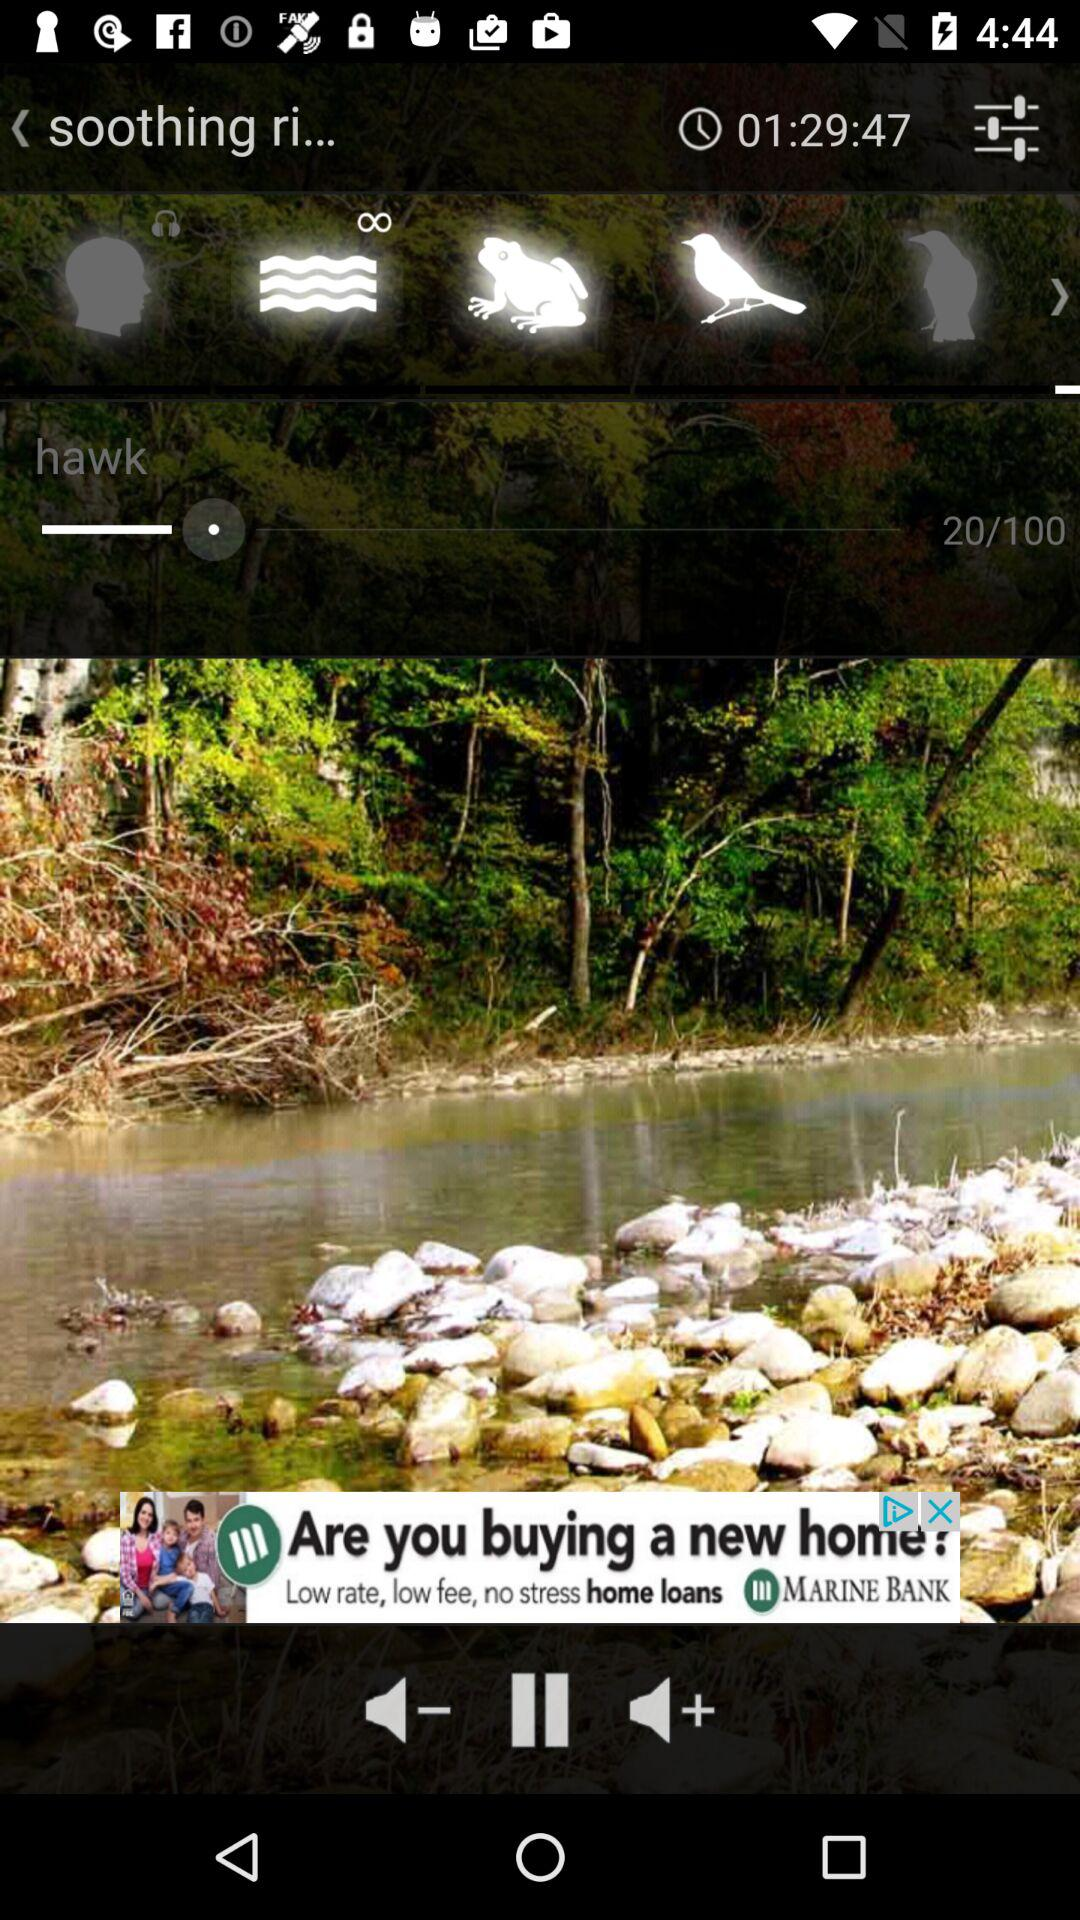What is the time displayed? The displayed time is 01:29:47. 